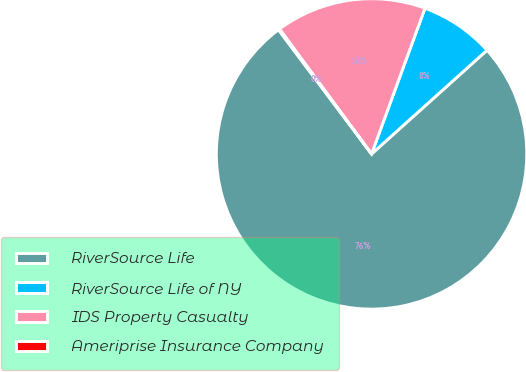Convert chart to OTSL. <chart><loc_0><loc_0><loc_500><loc_500><pie_chart><fcel>RiverSource Life<fcel>RiverSource Life of NY<fcel>IDS Property Casualty<fcel>Ameriprise Insurance Company<nl><fcel>76.41%<fcel>7.76%<fcel>15.7%<fcel>0.13%<nl></chart> 